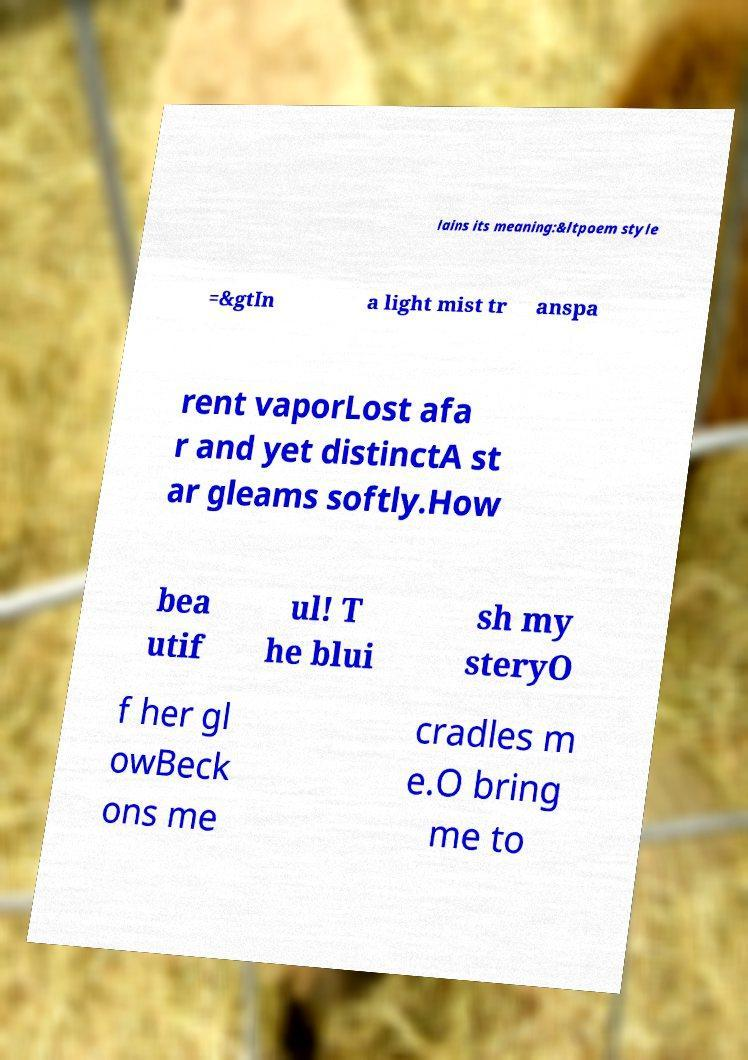What messages or text are displayed in this image? I need them in a readable, typed format. lains its meaning:&ltpoem style =&gtIn a light mist tr anspa rent vaporLost afa r and yet distinctA st ar gleams softly.How bea utif ul! T he blui sh my steryO f her gl owBeck ons me cradles m e.O bring me to 